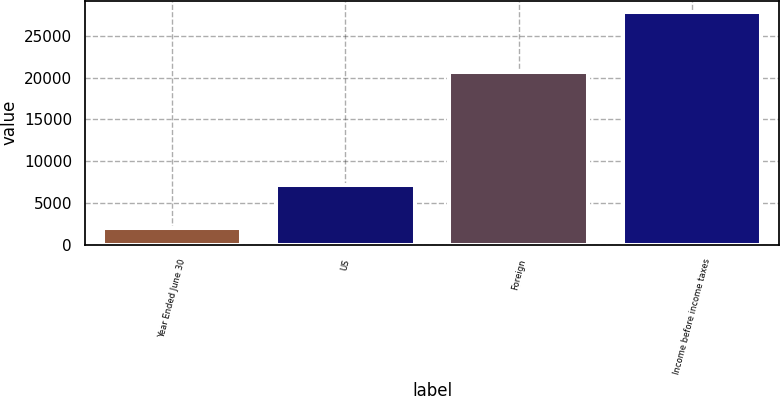Convert chart. <chart><loc_0><loc_0><loc_500><loc_500><bar_chart><fcel>Year Ended June 30<fcel>US<fcel>Foreign<fcel>Income before income taxes<nl><fcel>2014<fcel>7127<fcel>20693<fcel>27820<nl></chart> 